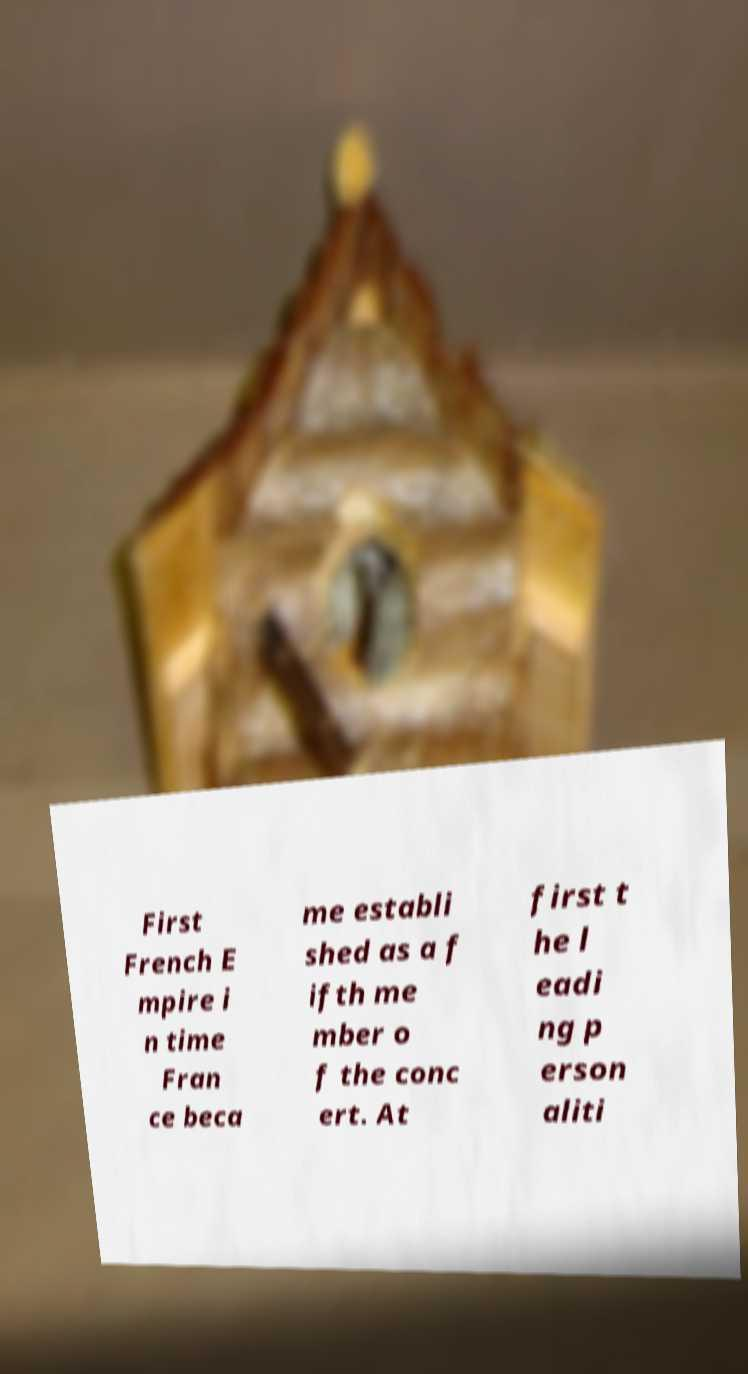Could you assist in decoding the text presented in this image and type it out clearly? First French E mpire i n time Fran ce beca me establi shed as a f ifth me mber o f the conc ert. At first t he l eadi ng p erson aliti 